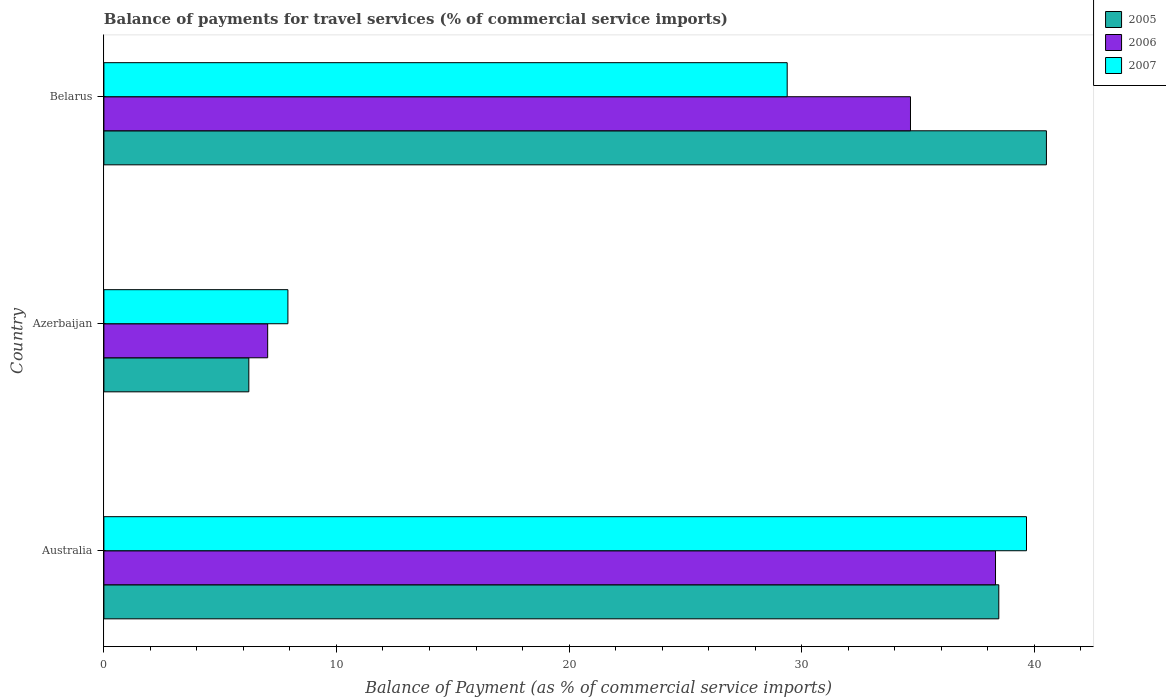How many groups of bars are there?
Provide a short and direct response. 3. Are the number of bars on each tick of the Y-axis equal?
Provide a short and direct response. Yes. How many bars are there on the 3rd tick from the top?
Ensure brevity in your answer.  3. How many bars are there on the 1st tick from the bottom?
Give a very brief answer. 3. What is the label of the 1st group of bars from the top?
Provide a succinct answer. Belarus. What is the balance of payments for travel services in 2005 in Azerbaijan?
Offer a very short reply. 6.23. Across all countries, what is the maximum balance of payments for travel services in 2007?
Provide a succinct answer. 39.67. Across all countries, what is the minimum balance of payments for travel services in 2007?
Provide a short and direct response. 7.91. In which country was the balance of payments for travel services in 2007 maximum?
Give a very brief answer. Australia. In which country was the balance of payments for travel services in 2007 minimum?
Your response must be concise. Azerbaijan. What is the total balance of payments for travel services in 2005 in the graph?
Make the answer very short. 85.24. What is the difference between the balance of payments for travel services in 2005 in Australia and that in Belarus?
Your answer should be very brief. -2.05. What is the difference between the balance of payments for travel services in 2007 in Belarus and the balance of payments for travel services in 2006 in Australia?
Keep it short and to the point. -8.96. What is the average balance of payments for travel services in 2006 per country?
Give a very brief answer. 26.69. What is the difference between the balance of payments for travel services in 2006 and balance of payments for travel services in 2005 in Azerbaijan?
Ensure brevity in your answer.  0.81. In how many countries, is the balance of payments for travel services in 2007 greater than 12 %?
Offer a terse response. 2. What is the ratio of the balance of payments for travel services in 2006 in Australia to that in Belarus?
Provide a short and direct response. 1.11. What is the difference between the highest and the second highest balance of payments for travel services in 2005?
Offer a very short reply. 2.05. What is the difference between the highest and the lowest balance of payments for travel services in 2006?
Offer a terse response. 31.3. In how many countries, is the balance of payments for travel services in 2007 greater than the average balance of payments for travel services in 2007 taken over all countries?
Provide a succinct answer. 2. What does the 2nd bar from the top in Australia represents?
Provide a succinct answer. 2006. What does the 1st bar from the bottom in Australia represents?
Provide a short and direct response. 2005. Are all the bars in the graph horizontal?
Your answer should be compact. Yes. What is the difference between two consecutive major ticks on the X-axis?
Provide a succinct answer. 10. Does the graph contain any zero values?
Provide a short and direct response. No. Does the graph contain grids?
Provide a succinct answer. No. How many legend labels are there?
Make the answer very short. 3. How are the legend labels stacked?
Your response must be concise. Vertical. What is the title of the graph?
Give a very brief answer. Balance of payments for travel services (% of commercial service imports). What is the label or title of the X-axis?
Provide a succinct answer. Balance of Payment (as % of commercial service imports). What is the label or title of the Y-axis?
Your answer should be compact. Country. What is the Balance of Payment (as % of commercial service imports) of 2005 in Australia?
Your answer should be compact. 38.48. What is the Balance of Payment (as % of commercial service imports) in 2006 in Australia?
Your response must be concise. 38.34. What is the Balance of Payment (as % of commercial service imports) in 2007 in Australia?
Ensure brevity in your answer.  39.67. What is the Balance of Payment (as % of commercial service imports) of 2005 in Azerbaijan?
Keep it short and to the point. 6.23. What is the Balance of Payment (as % of commercial service imports) in 2006 in Azerbaijan?
Your response must be concise. 7.04. What is the Balance of Payment (as % of commercial service imports) in 2007 in Azerbaijan?
Your answer should be compact. 7.91. What is the Balance of Payment (as % of commercial service imports) of 2005 in Belarus?
Offer a terse response. 40.53. What is the Balance of Payment (as % of commercial service imports) in 2006 in Belarus?
Give a very brief answer. 34.68. What is the Balance of Payment (as % of commercial service imports) of 2007 in Belarus?
Your answer should be compact. 29.38. Across all countries, what is the maximum Balance of Payment (as % of commercial service imports) of 2005?
Give a very brief answer. 40.53. Across all countries, what is the maximum Balance of Payment (as % of commercial service imports) of 2006?
Provide a short and direct response. 38.34. Across all countries, what is the maximum Balance of Payment (as % of commercial service imports) of 2007?
Provide a succinct answer. 39.67. Across all countries, what is the minimum Balance of Payment (as % of commercial service imports) in 2005?
Your response must be concise. 6.23. Across all countries, what is the minimum Balance of Payment (as % of commercial service imports) of 2006?
Give a very brief answer. 7.04. Across all countries, what is the minimum Balance of Payment (as % of commercial service imports) of 2007?
Make the answer very short. 7.91. What is the total Balance of Payment (as % of commercial service imports) in 2005 in the graph?
Your answer should be very brief. 85.24. What is the total Balance of Payment (as % of commercial service imports) of 2006 in the graph?
Make the answer very short. 80.06. What is the total Balance of Payment (as % of commercial service imports) in 2007 in the graph?
Offer a very short reply. 76.96. What is the difference between the Balance of Payment (as % of commercial service imports) of 2005 in Australia and that in Azerbaijan?
Provide a succinct answer. 32.25. What is the difference between the Balance of Payment (as % of commercial service imports) of 2006 in Australia and that in Azerbaijan?
Your response must be concise. 31.3. What is the difference between the Balance of Payment (as % of commercial service imports) in 2007 in Australia and that in Azerbaijan?
Ensure brevity in your answer.  31.76. What is the difference between the Balance of Payment (as % of commercial service imports) in 2005 in Australia and that in Belarus?
Offer a terse response. -2.05. What is the difference between the Balance of Payment (as % of commercial service imports) of 2006 in Australia and that in Belarus?
Your response must be concise. 3.66. What is the difference between the Balance of Payment (as % of commercial service imports) of 2007 in Australia and that in Belarus?
Keep it short and to the point. 10.29. What is the difference between the Balance of Payment (as % of commercial service imports) in 2005 in Azerbaijan and that in Belarus?
Your response must be concise. -34.3. What is the difference between the Balance of Payment (as % of commercial service imports) of 2006 in Azerbaijan and that in Belarus?
Offer a very short reply. -27.64. What is the difference between the Balance of Payment (as % of commercial service imports) in 2007 in Azerbaijan and that in Belarus?
Your answer should be compact. -21.47. What is the difference between the Balance of Payment (as % of commercial service imports) of 2005 in Australia and the Balance of Payment (as % of commercial service imports) of 2006 in Azerbaijan?
Keep it short and to the point. 31.44. What is the difference between the Balance of Payment (as % of commercial service imports) in 2005 in Australia and the Balance of Payment (as % of commercial service imports) in 2007 in Azerbaijan?
Offer a terse response. 30.57. What is the difference between the Balance of Payment (as % of commercial service imports) in 2006 in Australia and the Balance of Payment (as % of commercial service imports) in 2007 in Azerbaijan?
Your response must be concise. 30.43. What is the difference between the Balance of Payment (as % of commercial service imports) of 2005 in Australia and the Balance of Payment (as % of commercial service imports) of 2006 in Belarus?
Offer a very short reply. 3.8. What is the difference between the Balance of Payment (as % of commercial service imports) of 2005 in Australia and the Balance of Payment (as % of commercial service imports) of 2007 in Belarus?
Your answer should be compact. 9.1. What is the difference between the Balance of Payment (as % of commercial service imports) of 2006 in Australia and the Balance of Payment (as % of commercial service imports) of 2007 in Belarus?
Your response must be concise. 8.96. What is the difference between the Balance of Payment (as % of commercial service imports) in 2005 in Azerbaijan and the Balance of Payment (as % of commercial service imports) in 2006 in Belarus?
Offer a very short reply. -28.45. What is the difference between the Balance of Payment (as % of commercial service imports) of 2005 in Azerbaijan and the Balance of Payment (as % of commercial service imports) of 2007 in Belarus?
Make the answer very short. -23.15. What is the difference between the Balance of Payment (as % of commercial service imports) in 2006 in Azerbaijan and the Balance of Payment (as % of commercial service imports) in 2007 in Belarus?
Offer a very short reply. -22.34. What is the average Balance of Payment (as % of commercial service imports) of 2005 per country?
Make the answer very short. 28.41. What is the average Balance of Payment (as % of commercial service imports) in 2006 per country?
Your answer should be very brief. 26.69. What is the average Balance of Payment (as % of commercial service imports) of 2007 per country?
Provide a succinct answer. 25.65. What is the difference between the Balance of Payment (as % of commercial service imports) in 2005 and Balance of Payment (as % of commercial service imports) in 2006 in Australia?
Make the answer very short. 0.14. What is the difference between the Balance of Payment (as % of commercial service imports) of 2005 and Balance of Payment (as % of commercial service imports) of 2007 in Australia?
Offer a very short reply. -1.19. What is the difference between the Balance of Payment (as % of commercial service imports) of 2006 and Balance of Payment (as % of commercial service imports) of 2007 in Australia?
Give a very brief answer. -1.33. What is the difference between the Balance of Payment (as % of commercial service imports) of 2005 and Balance of Payment (as % of commercial service imports) of 2006 in Azerbaijan?
Your answer should be compact. -0.81. What is the difference between the Balance of Payment (as % of commercial service imports) of 2005 and Balance of Payment (as % of commercial service imports) of 2007 in Azerbaijan?
Keep it short and to the point. -1.68. What is the difference between the Balance of Payment (as % of commercial service imports) of 2006 and Balance of Payment (as % of commercial service imports) of 2007 in Azerbaijan?
Offer a terse response. -0.87. What is the difference between the Balance of Payment (as % of commercial service imports) of 2005 and Balance of Payment (as % of commercial service imports) of 2006 in Belarus?
Offer a very short reply. 5.85. What is the difference between the Balance of Payment (as % of commercial service imports) in 2005 and Balance of Payment (as % of commercial service imports) in 2007 in Belarus?
Provide a succinct answer. 11.15. What is the difference between the Balance of Payment (as % of commercial service imports) in 2006 and Balance of Payment (as % of commercial service imports) in 2007 in Belarus?
Ensure brevity in your answer.  5.3. What is the ratio of the Balance of Payment (as % of commercial service imports) in 2005 in Australia to that in Azerbaijan?
Your response must be concise. 6.17. What is the ratio of the Balance of Payment (as % of commercial service imports) of 2006 in Australia to that in Azerbaijan?
Offer a terse response. 5.44. What is the ratio of the Balance of Payment (as % of commercial service imports) in 2007 in Australia to that in Azerbaijan?
Your answer should be compact. 5.01. What is the ratio of the Balance of Payment (as % of commercial service imports) of 2005 in Australia to that in Belarus?
Ensure brevity in your answer.  0.95. What is the ratio of the Balance of Payment (as % of commercial service imports) in 2006 in Australia to that in Belarus?
Ensure brevity in your answer.  1.11. What is the ratio of the Balance of Payment (as % of commercial service imports) of 2007 in Australia to that in Belarus?
Offer a terse response. 1.35. What is the ratio of the Balance of Payment (as % of commercial service imports) of 2005 in Azerbaijan to that in Belarus?
Give a very brief answer. 0.15. What is the ratio of the Balance of Payment (as % of commercial service imports) in 2006 in Azerbaijan to that in Belarus?
Your answer should be compact. 0.2. What is the ratio of the Balance of Payment (as % of commercial service imports) of 2007 in Azerbaijan to that in Belarus?
Provide a short and direct response. 0.27. What is the difference between the highest and the second highest Balance of Payment (as % of commercial service imports) in 2005?
Your answer should be very brief. 2.05. What is the difference between the highest and the second highest Balance of Payment (as % of commercial service imports) in 2006?
Offer a terse response. 3.66. What is the difference between the highest and the second highest Balance of Payment (as % of commercial service imports) in 2007?
Your response must be concise. 10.29. What is the difference between the highest and the lowest Balance of Payment (as % of commercial service imports) of 2005?
Offer a very short reply. 34.3. What is the difference between the highest and the lowest Balance of Payment (as % of commercial service imports) in 2006?
Ensure brevity in your answer.  31.3. What is the difference between the highest and the lowest Balance of Payment (as % of commercial service imports) in 2007?
Offer a terse response. 31.76. 